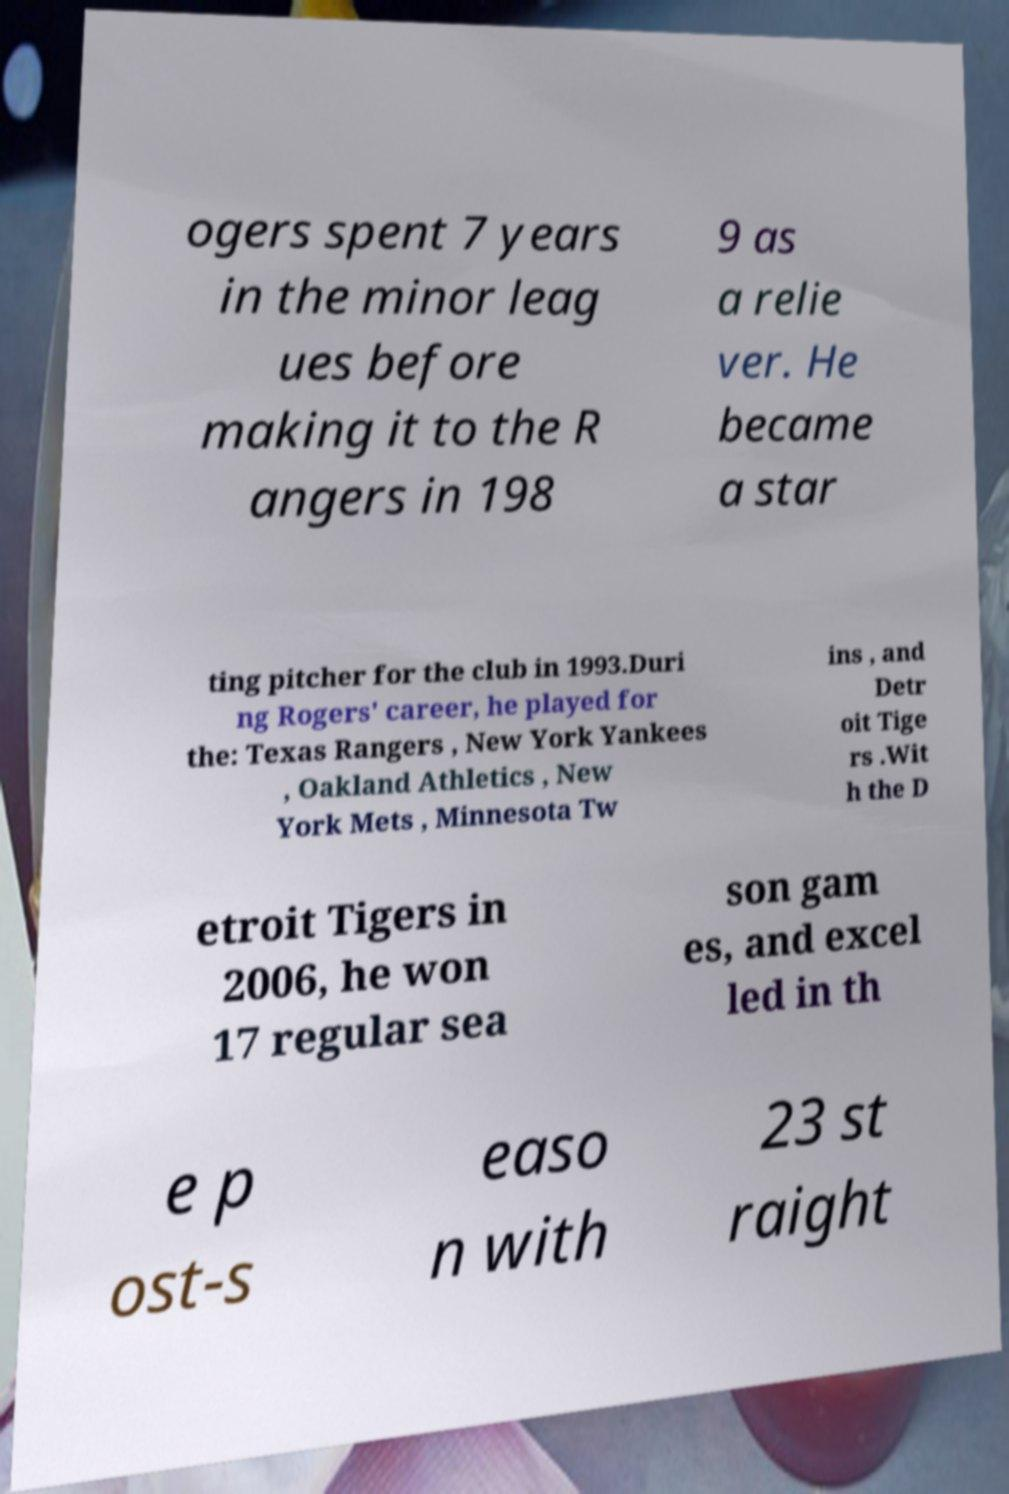I need the written content from this picture converted into text. Can you do that? ogers spent 7 years in the minor leag ues before making it to the R angers in 198 9 as a relie ver. He became a star ting pitcher for the club in 1993.Duri ng Rogers' career, he played for the: Texas Rangers , New York Yankees , Oakland Athletics , New York Mets , Minnesota Tw ins , and Detr oit Tige rs .Wit h the D etroit Tigers in 2006, he won 17 regular sea son gam es, and excel led in th e p ost-s easo n with 23 st raight 